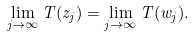<formula> <loc_0><loc_0><loc_500><loc_500>\lim _ { j \to \infty } T ( z _ { j } ) = \lim _ { j \to \infty } T ( w _ { j } ) .</formula> 